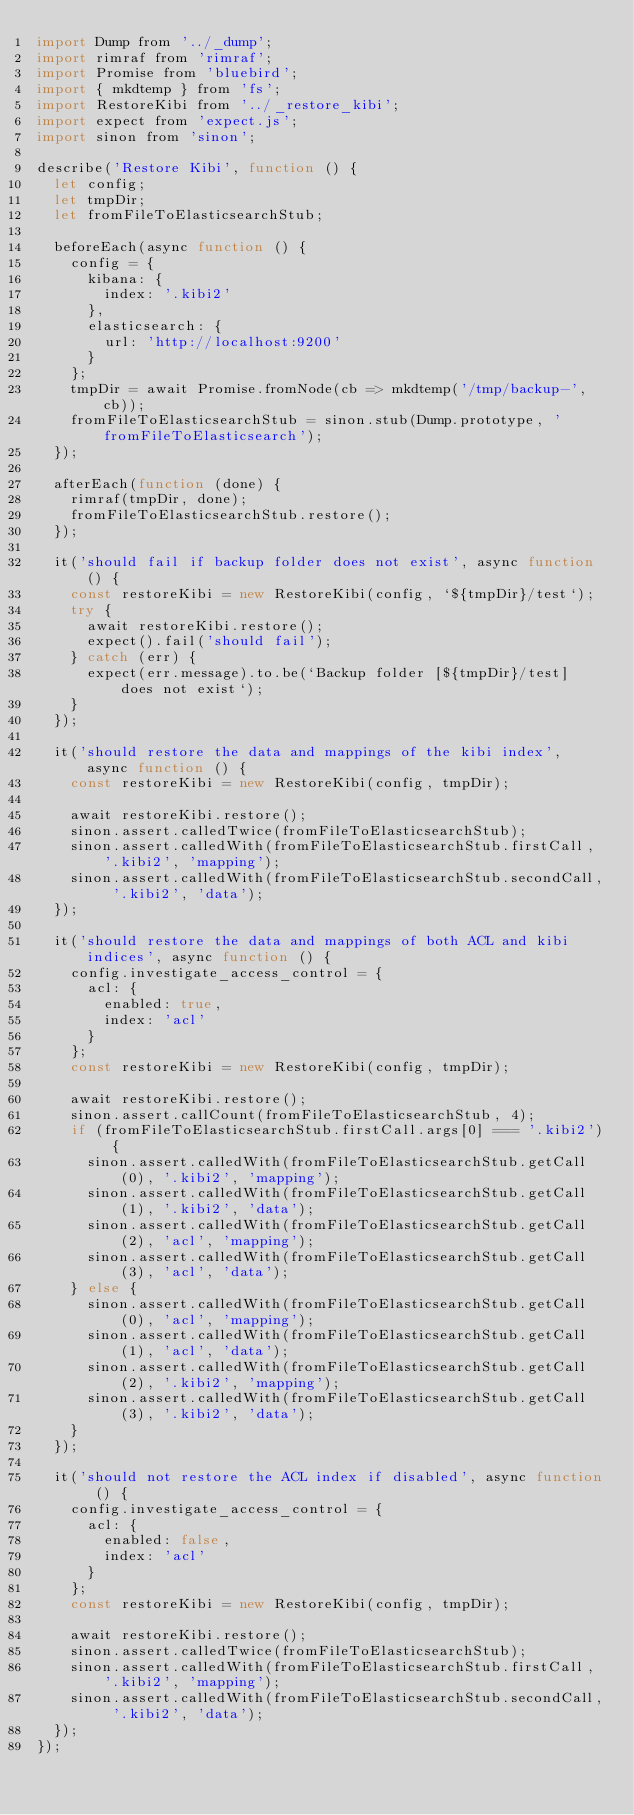<code> <loc_0><loc_0><loc_500><loc_500><_JavaScript_>import Dump from '../_dump';
import rimraf from 'rimraf';
import Promise from 'bluebird';
import { mkdtemp } from 'fs';
import RestoreKibi from '../_restore_kibi';
import expect from 'expect.js';
import sinon from 'sinon';

describe('Restore Kibi', function () {
  let config;
  let tmpDir;
  let fromFileToElasticsearchStub;

  beforeEach(async function () {
    config = {
      kibana: {
        index: '.kibi2'
      },
      elasticsearch: {
        url: 'http://localhost:9200'
      }
    };
    tmpDir = await Promise.fromNode(cb => mkdtemp('/tmp/backup-', cb));
    fromFileToElasticsearchStub = sinon.stub(Dump.prototype, 'fromFileToElasticsearch');
  });

  afterEach(function (done) {
    rimraf(tmpDir, done);
    fromFileToElasticsearchStub.restore();
  });

  it('should fail if backup folder does not exist', async function () {
    const restoreKibi = new RestoreKibi(config, `${tmpDir}/test`);
    try {
      await restoreKibi.restore();
      expect().fail('should fail');
    } catch (err) {
      expect(err.message).to.be(`Backup folder [${tmpDir}/test] does not exist`);
    }
  });

  it('should restore the data and mappings of the kibi index', async function () {
    const restoreKibi = new RestoreKibi(config, tmpDir);

    await restoreKibi.restore();
    sinon.assert.calledTwice(fromFileToElasticsearchStub);
    sinon.assert.calledWith(fromFileToElasticsearchStub.firstCall, '.kibi2', 'mapping');
    sinon.assert.calledWith(fromFileToElasticsearchStub.secondCall, '.kibi2', 'data');
  });

  it('should restore the data and mappings of both ACL and kibi indices', async function () {
    config.investigate_access_control = {
      acl: {
        enabled: true,
        index: 'acl'
      }
    };
    const restoreKibi = new RestoreKibi(config, tmpDir);

    await restoreKibi.restore();
    sinon.assert.callCount(fromFileToElasticsearchStub, 4);
    if (fromFileToElasticsearchStub.firstCall.args[0] === '.kibi2') {
      sinon.assert.calledWith(fromFileToElasticsearchStub.getCall(0), '.kibi2', 'mapping');
      sinon.assert.calledWith(fromFileToElasticsearchStub.getCall(1), '.kibi2', 'data');
      sinon.assert.calledWith(fromFileToElasticsearchStub.getCall(2), 'acl', 'mapping');
      sinon.assert.calledWith(fromFileToElasticsearchStub.getCall(3), 'acl', 'data');
    } else {
      sinon.assert.calledWith(fromFileToElasticsearchStub.getCall(0), 'acl', 'mapping');
      sinon.assert.calledWith(fromFileToElasticsearchStub.getCall(1), 'acl', 'data');
      sinon.assert.calledWith(fromFileToElasticsearchStub.getCall(2), '.kibi2', 'mapping');
      sinon.assert.calledWith(fromFileToElasticsearchStub.getCall(3), '.kibi2', 'data');
    }
  });

  it('should not restore the ACL index if disabled', async function () {
    config.investigate_access_control = {
      acl: {
        enabled: false,
        index: 'acl'
      }
    };
    const restoreKibi = new RestoreKibi(config, tmpDir);

    await restoreKibi.restore();
    sinon.assert.calledTwice(fromFileToElasticsearchStub);
    sinon.assert.calledWith(fromFileToElasticsearchStub.firstCall, '.kibi2', 'mapping');
    sinon.assert.calledWith(fromFileToElasticsearchStub.secondCall, '.kibi2', 'data');
  });
});
</code> 